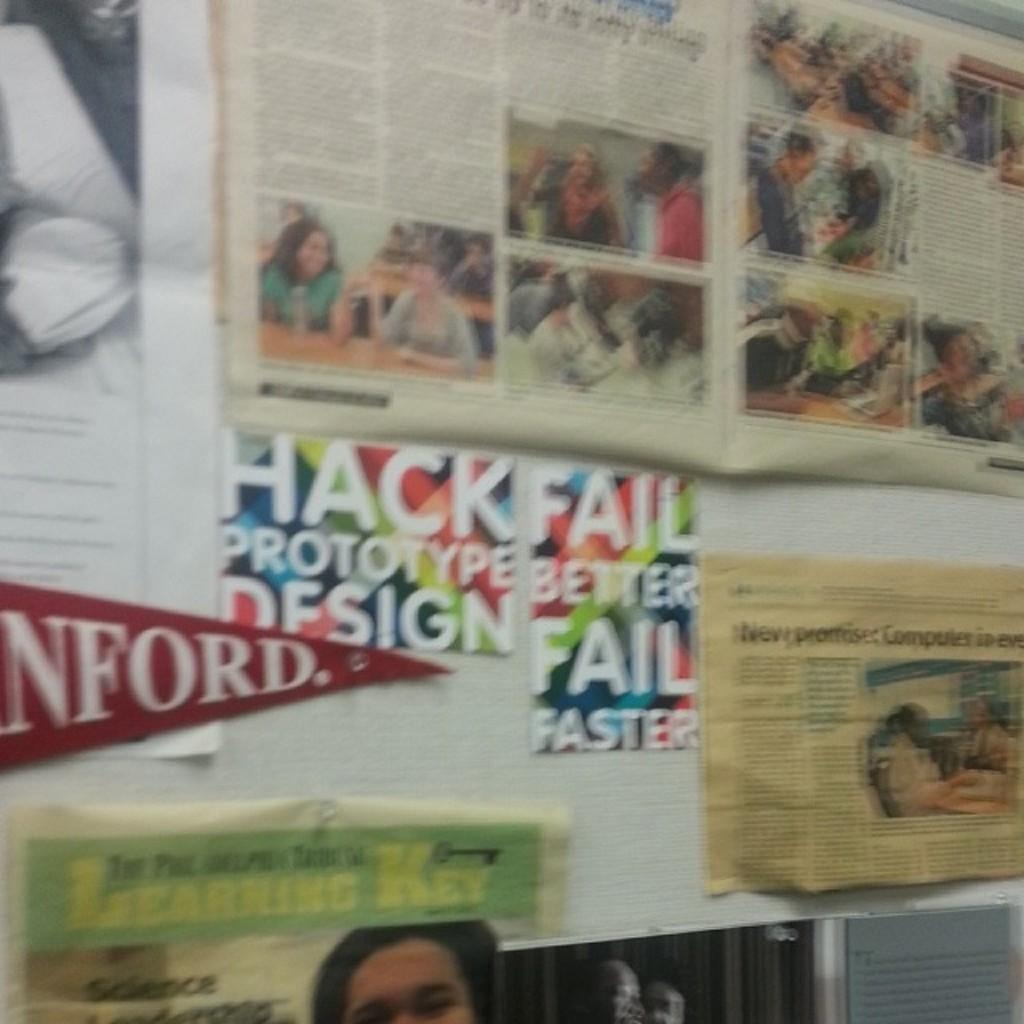Provide a one-sentence caption for the provided image. A red Stanford college banner is partially visible hanging on the wall. 